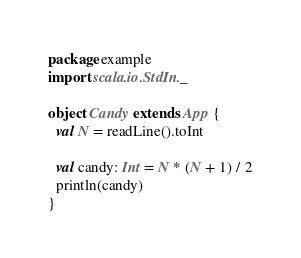<code> <loc_0><loc_0><loc_500><loc_500><_Scala_>package example
import scala.io.StdIn._

object Candy extends App {
  val N = readLine().toInt

  val candy: Int = N * (N + 1) / 2
  println(candy)
}</code> 